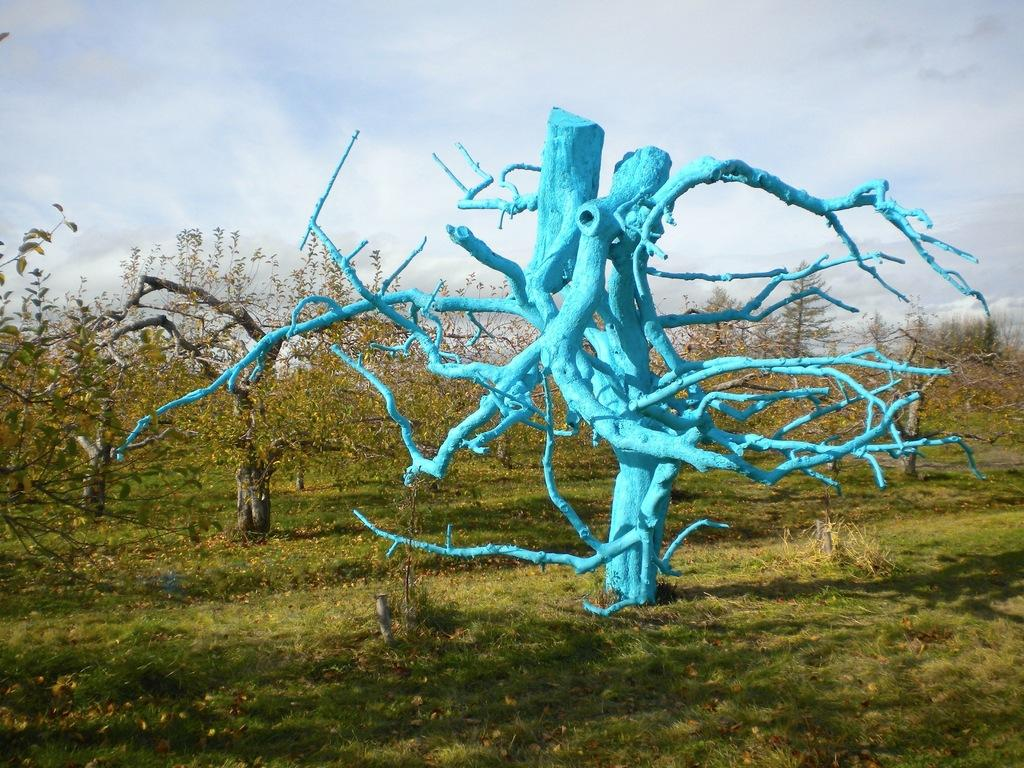What type of vegetation is predominant in the image? There are many trees in the image. Can you describe a specific tree in the image? There is a painted tree in the image. What is the ground like in the image? There is a grassy land in the image. How would you describe the weather in the image? The sky is cloudy in the image. How many letters are being delivered to the trees in the image? There are no letters being delivered to the trees in the image; it only shows trees and a painted tree. 